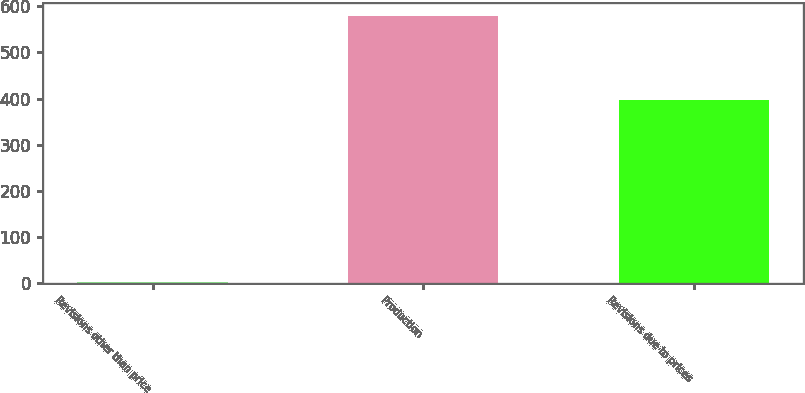Convert chart. <chart><loc_0><loc_0><loc_500><loc_500><bar_chart><fcel>Revisions other than price<fcel>Production<fcel>Revisions due to prices<nl><fcel>3<fcel>579<fcel>398<nl></chart> 